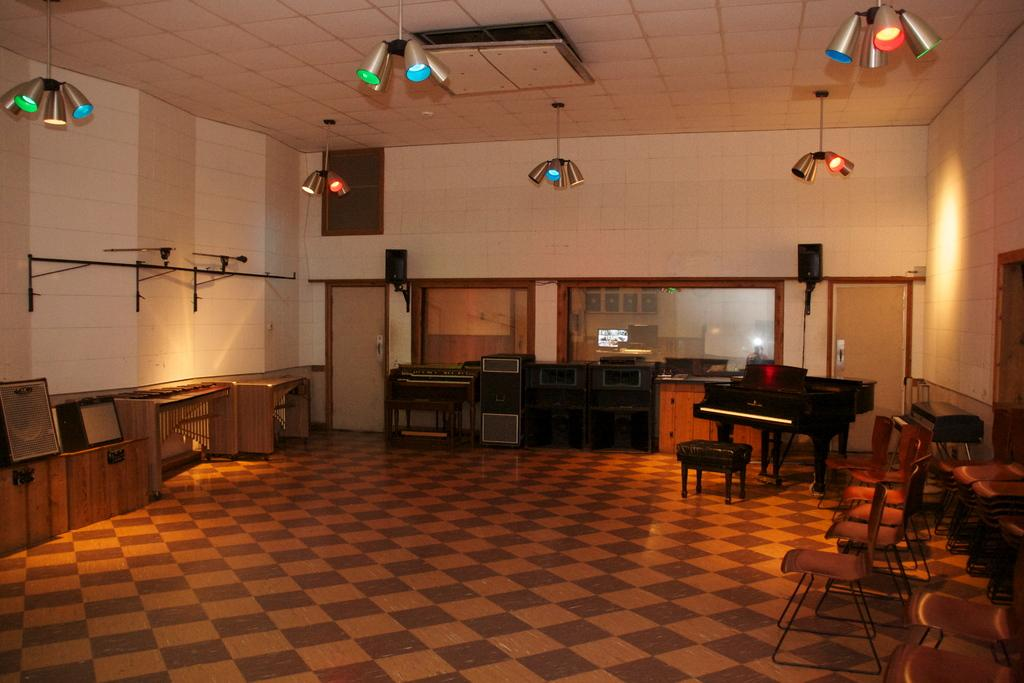What type of space is shown in the image? The image depicts a room. What furniture can be seen in the room? There are multiple chairs in the room. What musical instrument is present in the room? There is a piano in the room. What can be used to provide illumination in the room? There are lights visible in the room. How does the crowd in the image react to the piano performance? There is no crowd present in the image; it only shows a room with chairs, a piano, and lights. 